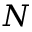Convert formula to latex. <formula><loc_0><loc_0><loc_500><loc_500>N</formula> 